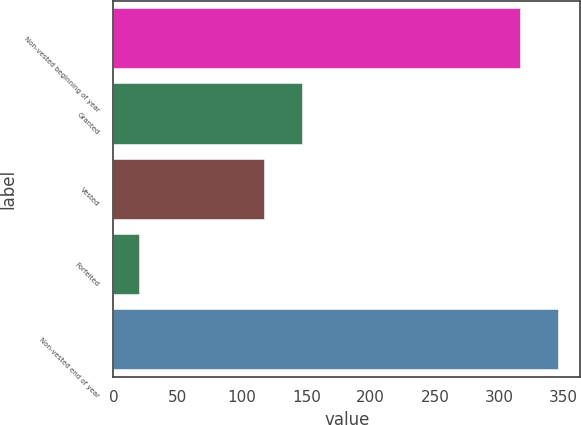<chart> <loc_0><loc_0><loc_500><loc_500><bar_chart><fcel>Non-vested beginning of year<fcel>Granted<fcel>Vested<fcel>Forfeited<fcel>Non-vested end of year<nl><fcel>316<fcel>146.8<fcel>117<fcel>20<fcel>345.8<nl></chart> 